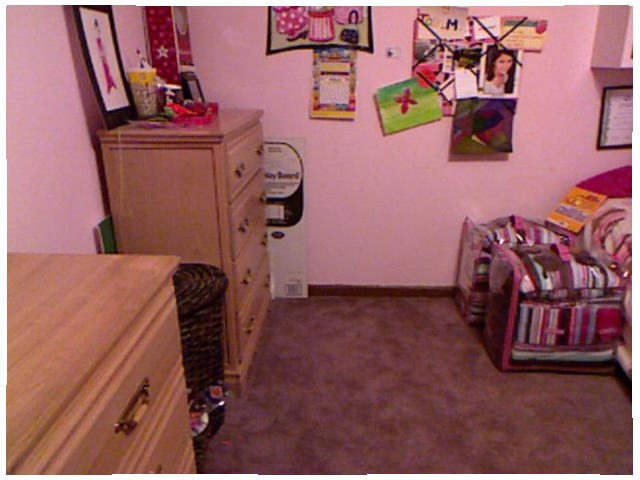<image>
Can you confirm if the poster is in front of the dresser? No. The poster is not in front of the dresser. The spatial positioning shows a different relationship between these objects. Is the dresser in front of the poster board? No. The dresser is not in front of the poster board. The spatial positioning shows a different relationship between these objects. Is the calendar on the wall? No. The calendar is not positioned on the wall. They may be near each other, but the calendar is not supported by or resting on top of the wall. Is there a poster above the dresser? Yes. The poster is positioned above the dresser in the vertical space, higher up in the scene. 